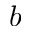Convert formula to latex. <formula><loc_0><loc_0><loc_500><loc_500>b</formula> 